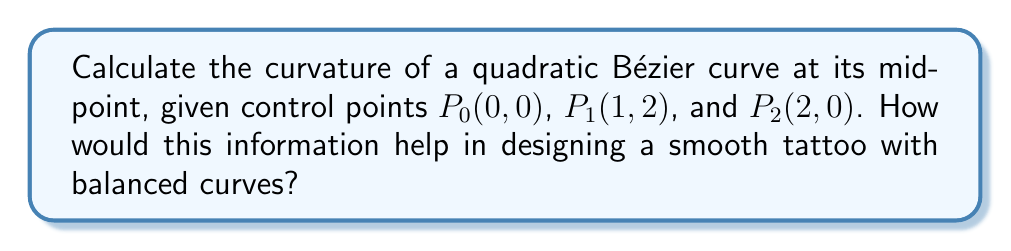Can you answer this question? To calculate the curvature of a quadratic Bézier curve at its midpoint, we'll follow these steps:

1) The quadratic Bézier curve is defined by:
   $$B(t) = (1-t)^2P_0 + 2t(1-t)P_1 + t^2P_2, \quad 0 \leq t \leq 1$$

2) The first derivative is:
   $$B'(t) = 2(1-t)(P_1-P_0) + 2t(P_2-P_1)$$

3) The second derivative is:
   $$B''(t) = 2(P_2-2P_1+P_0)$$

4) The curvature formula for a parametric curve is:
   $$\kappa(t) = \frac{|B'(t) \times B''(t)|}{|B'(t)|^3}$$

5) At the midpoint, $t=0.5$. Let's calculate $B'(0.5)$ and $B''(0.5)$:
   $$B'(0.5) = (P_1-P_0) + (P_2-P_1) = P_2 - P_0 = (2,0)$$
   $$B''(0.5) = 2(P_2-2P_1+P_0) = 2((2,0)-2(1,2)+(0,0)) = (0,-8)$$

6) Now, let's calculate the cross product and magnitudes:
   $$|B'(0.5) \times B''(0.5)| = |2 \cdot (-8) - 0 \cdot 0| = 16$$
   $$|B'(0.5)|^3 = (2^2 + 0^2)^{3/2} = 8$$

7) Finally, we can calculate the curvature:
   $$\kappa(0.5) = \frac{16}{8} = 2$$

This curvature value helps in designing smooth tattoos by indicating how sharply the curve bends at its midpoint. A higher curvature means a sharper bend, while a lower curvature indicates a gentler curve. Balancing these curvatures across a design can create visually pleasing and harmonious tattoo patterns.
Answer: $\kappa(0.5) = 2$ 